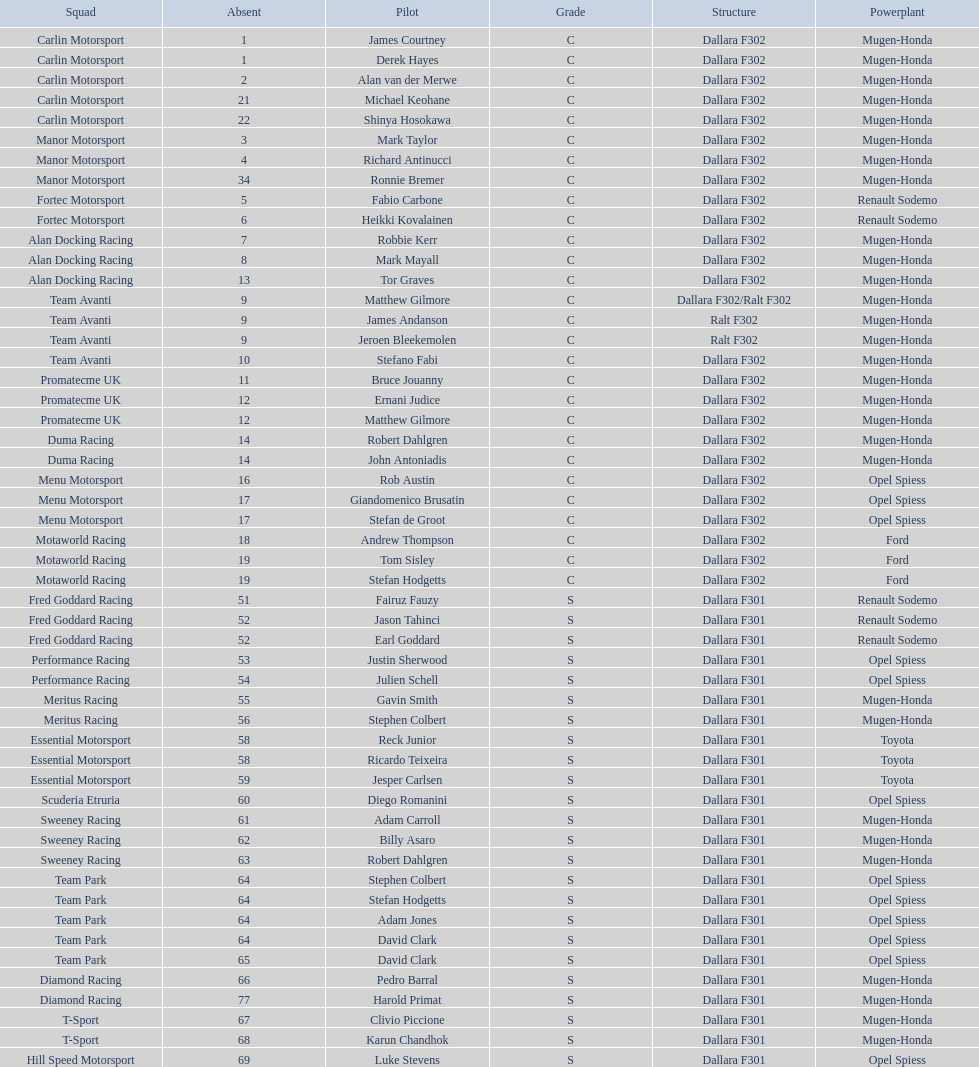What team is listed above diamond racing? Team Park. 